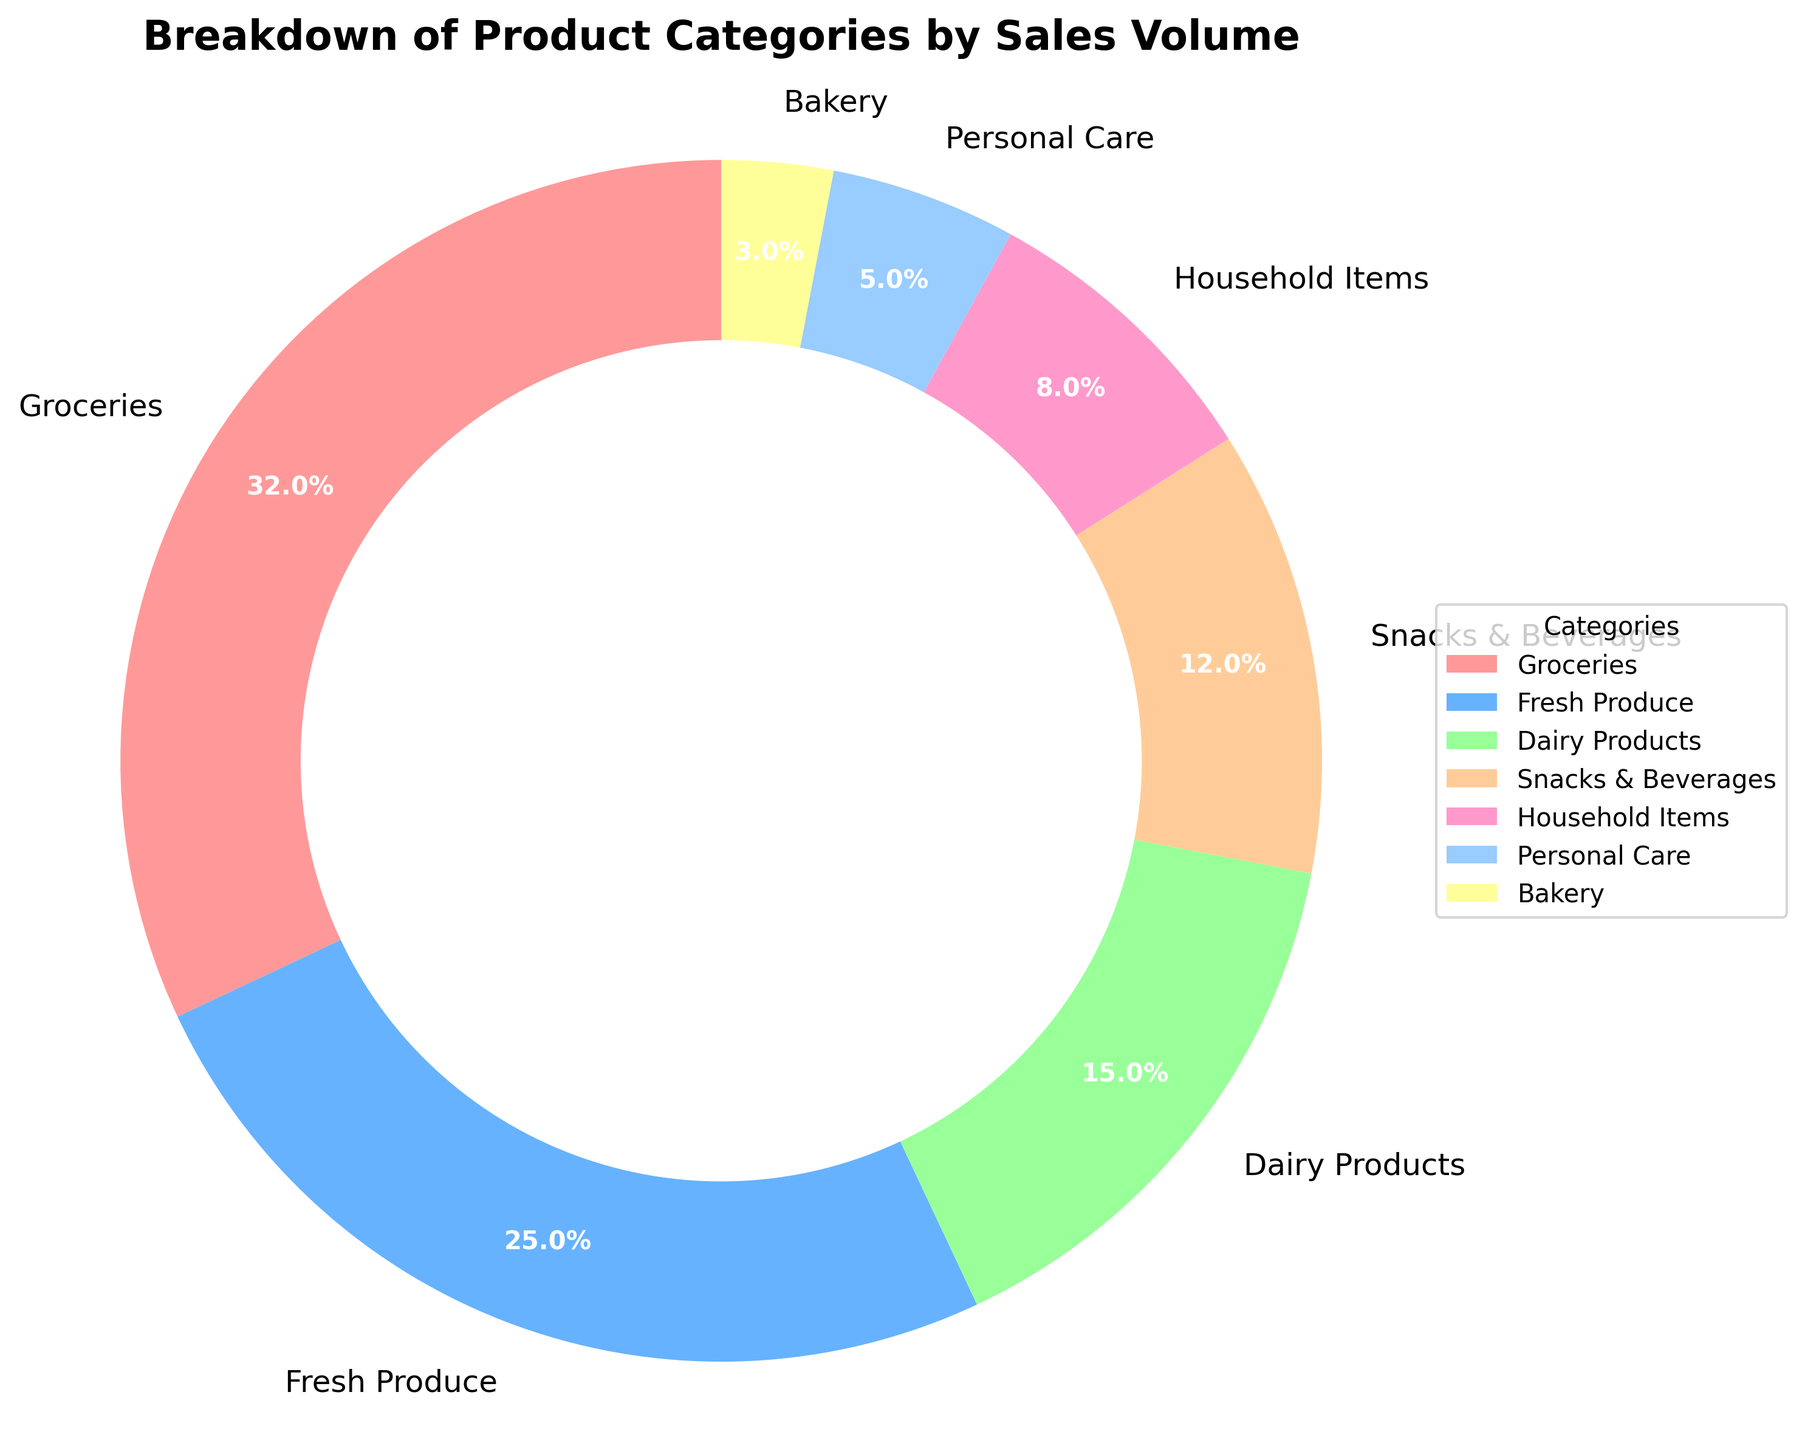Which category has the highest sales volume? By looking at the pie chart, the segment representing Groceries is the largest slice, indicating that it has the highest sales volume.
Answer: Groceries How much higher is the sales volume of Groceries compared to Fresh Produce? Groceries has a sales volume of 32, while Fresh Produce has 25. The difference between them is 32 - 25 = 7.
Answer: 7 What percentage of the total sales does Snacks & Beverages represent? The pie chart shows that Snacks & Beverages represent 12% of the total sales. This can be directly read from the chart as its percentage is labeled.
Answer: 12% What two categories together make up half of the total sales volume? Groceries make up 32% and Fresh Produce make up 25%. Adding these two percentages gives 32% + 25% = 57%, which is more than half but is the closest proportion made by two categories.
Answer: Groceries and Fresh Produce What is the combined percentage of sales for Dairy Products and Household Items? Dairy Products account for 15% and Household Items account for 8%. Adding these percentages gives 15% + 8% = 23%.
Answer: 23% Which category has a smaller sales volume, Bakery or Personal Care? Comparing the slices for Bakery and Personal Care, we see that Bakery represents 3% of the sales volume whereas Personal Care represents 5%. Therefore, Bakery has a smaller sales volume.
Answer: Bakery What is the percentage difference between the sales volumes of Personal Care and Household Items? Personal Care accounts for 5% and Household Items account for 8%. The percentage difference is calculated as 8% - 5% = 3%.
Answer: 3% What is the total sales volume for categories that each have less than 10% of the total pie? Categories with less than 10% are Household Items (8%), Personal Care (5%), and Bakery (3%). Adding these gives 8% + 5% + 3% = 16%.
Answer: 16% 